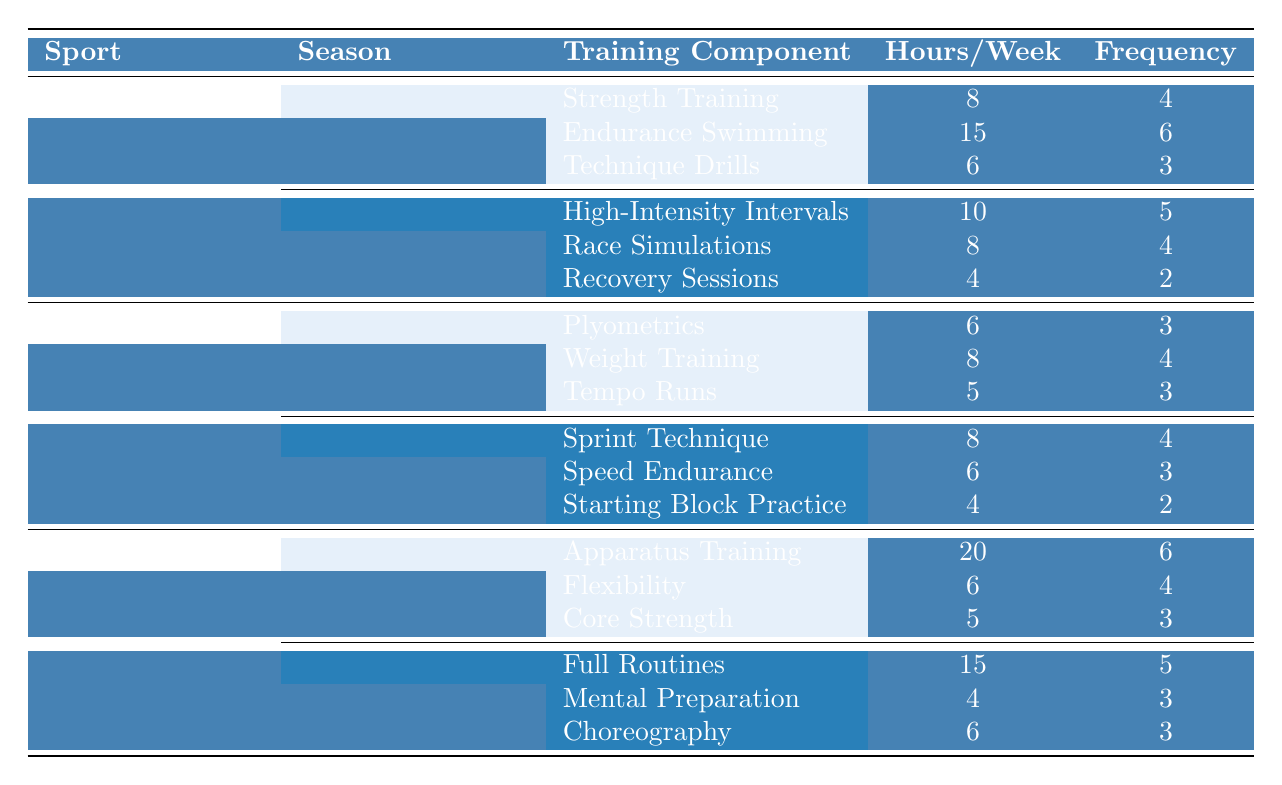What is the total number of hours an athlete trains per week during the Off-Season for Swimming? In the Off-Season for Swimming, the training components are Strength Training (8 hours), Endurance Swimming (15 hours), and Technique Drills (6 hours). Adding these together gives 8 + 15 + 6 = 29 hours per week.
Answer: 29 hours Which training component has the highest frequency during the Pre-Competition season in Swimming? In the Pre-Competition season, the training components are High-Intensity Intervals (5), Race Simulations (4), and Recovery Sessions (2). The highest frequency is 5 for High-Intensity Intervals.
Answer: High-Intensity Intervals Is the total training hours in the Base Building season for Track and Field less than that in the Off-Season for Swimming? In the Base Building season, the components are Plyometrics (6), Weight Training (8), and Tempo Runs (5). The total is 6 + 8 + 5 = 19 hours. In the Off-Season for Swimming, the total is 29 hours. Since 19 is less than 29, the answer is yes.
Answer: Yes How much more weekly training time is dedicated to Apparatus Training in Gymnastics compared to Recovery Sessions in Swimming? Apparatus Training in Gymnastics is 20 hours per week, while Recovery Sessions in Swimming is 4 hours per week. The difference is 20 - 4 = 16 hours.
Answer: 16 hours What is the average frequency of training components in the Competition Phase for Track and Field? In the Competition Phase, the training components are Sprint Technique (4), Speed Endurance (3), and Starting Block Practice (2). The total frequency is 4 + 3 + 2 = 9. The average frequency is 9 / 3 = 3.
Answer: 3 In which season does Gymnastics feature the most training hours, and how many hours are dedicated? Gymnastics has Skill Development season with 20 hours for Apparatus Training, 6 for Flexibility, and 5 for Core Strength, totaling 31 hours. The Routine Perfection season has Full Routines (15) + Mental Preparation (4) + Choreography (6) = 25 hours. Therefore, Skill Development features the most hours.
Answer: Skill Development, 31 hours Is the total training hours during the Routine Perfection season greater than during the Competition Phase for Track and Field? Routine Perfection season has 15 + 4 + 6 = 25 hours. Competition Phase has 8 + 6 + 4 = 18 hours. Since 25 is greater than 18, the answer is yes.
Answer: Yes What components contribute to the highest total training time for a single sport across seasons? For Swimming the total is 29 in Off-Season; for Track and Field, Base Building gives 19 and Competition Phase gives 18 for a max of 19; Gymnastics has 31 in Skill Development and 25 in Routine Perfection, the highest being 31.
Answer: Gymnastics, 31 hours Which sport has a Total Weekly training session frequency of 10 or more during any season? Swimming has 6 (Off-Season) and 3 (Pre-Competition), totaling 9; Track and Field has 3 (Base Building) and 3 (Competition Phase), totaling 6; Gymnastics has 6 (Skill Development) and 3 (Routine Perfection), totaling 9. None exceed 10 in total frequencies.
Answer: None 